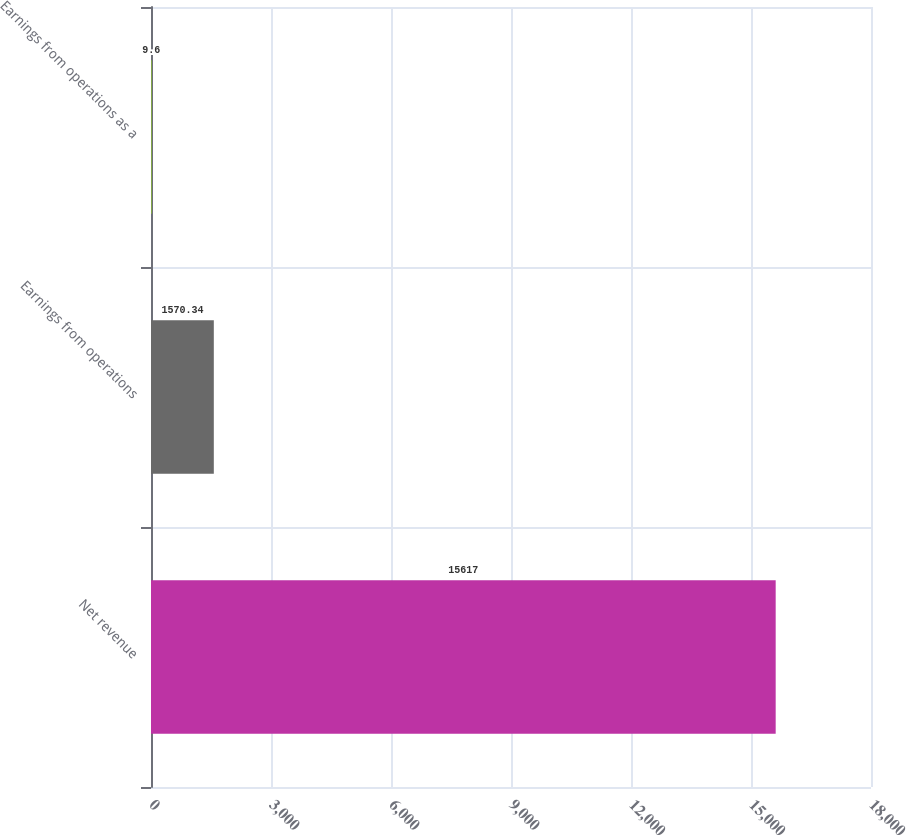<chart> <loc_0><loc_0><loc_500><loc_500><bar_chart><fcel>Net revenue<fcel>Earnings from operations<fcel>Earnings from operations as a<nl><fcel>15617<fcel>1570.34<fcel>9.6<nl></chart> 